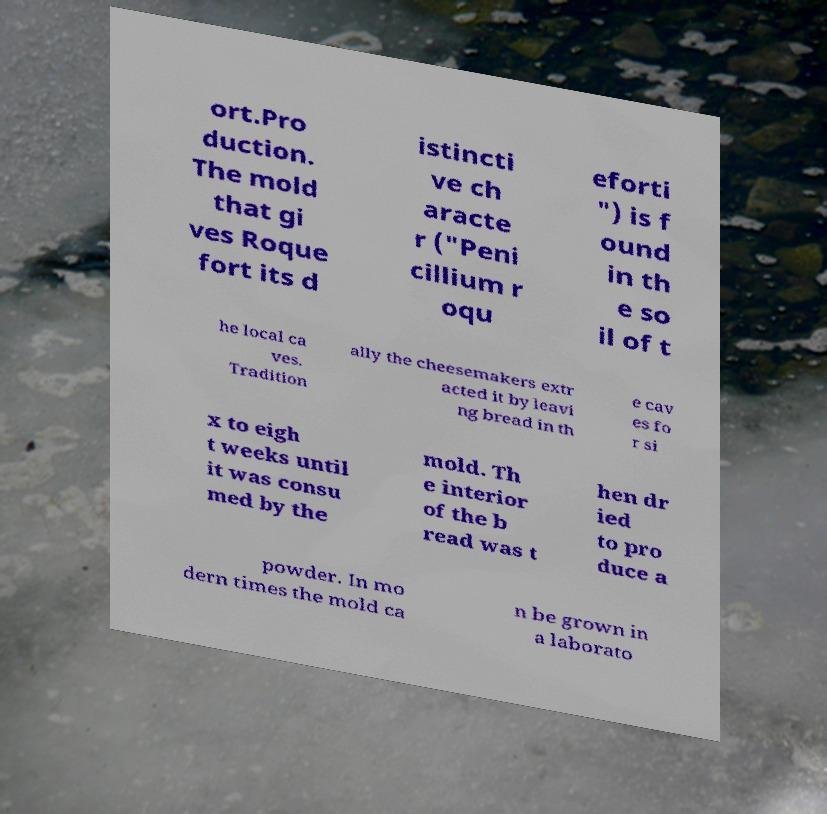Could you assist in decoding the text presented in this image and type it out clearly? ort.Pro duction. The mold that gi ves Roque fort its d istincti ve ch aracte r ("Peni cillium r oqu eforti ") is f ound in th e so il of t he local ca ves. Tradition ally the cheesemakers extr acted it by leavi ng bread in th e cav es fo r si x to eigh t weeks until it was consu med by the mold. Th e interior of the b read was t hen dr ied to pro duce a powder. In mo dern times the mold ca n be grown in a laborato 